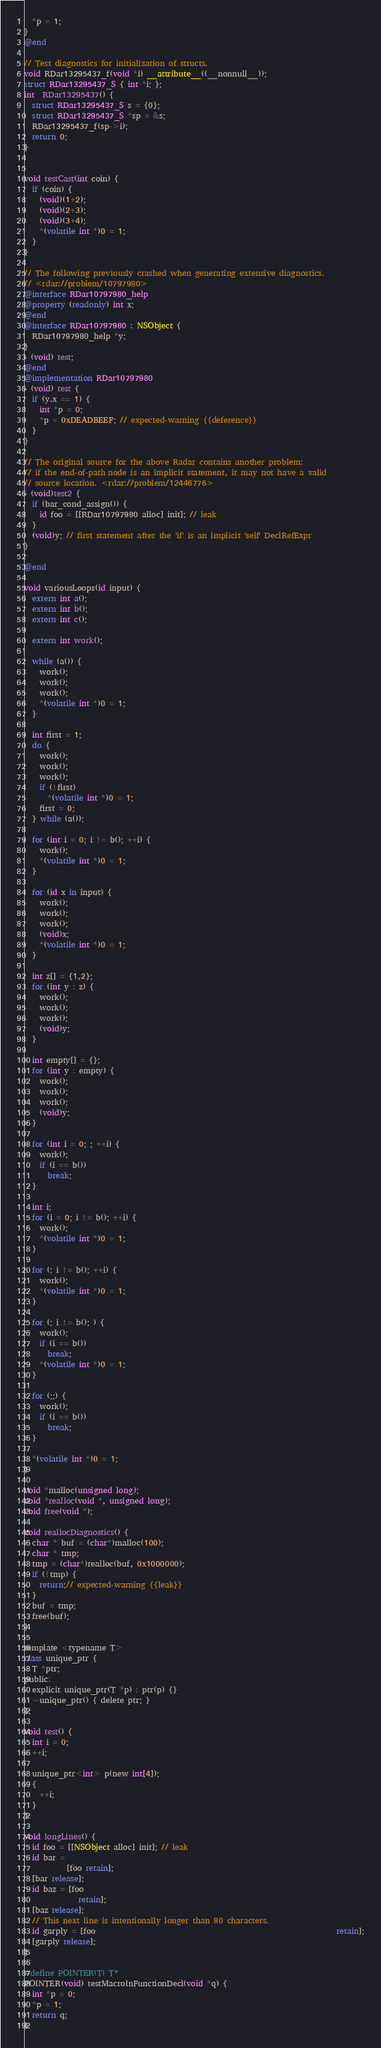Convert code to text. <code><loc_0><loc_0><loc_500><loc_500><_ObjectiveC_>  *p = 1;
}
@end

// Test diagnostics for initialization of structs.
void RDar13295437_f(void *i) __attribute__((__nonnull__));
struct RDar13295437_S { int *i; };
int  RDar13295437() {
  struct RDar13295437_S s = {0};
  struct RDar13295437_S *sp = &s;
  RDar13295437_f(sp->i);
  return 0;
}


void testCast(int coin) {
  if (coin) {
    (void)(1+2);
    (void)(2+3);
    (void)(3+4);
    *(volatile int *)0 = 1;
  }
}

// The following previously crashed when generating extensive diagnostics.
// <rdar://problem/10797980>
@interface RDar10797980_help
@property (readonly) int x;
@end
@interface RDar10797980 : NSObject {
  RDar10797980_help *y;
}
- (void) test;
@end
@implementation RDar10797980
- (void) test {
  if (y.x == 1) {
    int *p = 0;
    *p = 0xDEADBEEF; // expected-warning {{deference}}
  }
}

// The original source for the above Radar contains another problem:
// if the end-of-path node is an implicit statement, it may not have a valid
// source location. <rdar://problem/12446776>
- (void)test2 {
  if (bar_cond_assign()) {
    id foo = [[RDar10797980 alloc] init]; // leak
  }
  (void)y; // first statement after the 'if' is an implicit 'self' DeclRefExpr
}

@end

void variousLoops(id input) {
  extern int a();
  extern int b();
  extern int c();

  extern int work();

  while (a()) {
    work();
    work();
    work();
    *(volatile int *)0 = 1;
  }

  int first = 1;
  do {
    work();
    work();
    work();
    if (!first)
      *(volatile int *)0 = 1;
    first = 0;
  } while (a());

  for (int i = 0; i != b(); ++i) {
    work();
    *(volatile int *)0 = 1;
  }

  for (id x in input) {
    work();
    work();
    work();
    (void)x;
    *(volatile int *)0 = 1;
  }

  int z[] = {1,2};
  for (int y : z) {
    work();
    work();
    work();
    (void)y;
  }

  int empty[] = {};
  for (int y : empty) {
    work();
    work();
    work();
    (void)y;
  }

  for (int i = 0; ; ++i) {
    work();
    if (i == b())
      break;
  }

  int i;
  for (i = 0; i != b(); ++i) {
    work();
    *(volatile int *)0 = 1;
  }

  for (; i != b(); ++i) {
    work();
    *(volatile int *)0 = 1;
  }

  for (; i != b(); ) {
    work();
    if (i == b())
      break;
    *(volatile int *)0 = 1;
  }

  for (;;) {
    work();
    if (i == b())
      break;
  }

  *(volatile int *)0 = 1;
}

void *malloc(unsigned long);
void *realloc(void *, unsigned long);
void free(void *);

void reallocDiagnostics() {
  char * buf = (char*)malloc(100);
  char * tmp;
  tmp = (char*)realloc(buf, 0x1000000);
  if (!tmp) {
    return;// expected-warning {{leak}}
  }
  buf = tmp;
  free(buf);
}

template <typename T>
class unique_ptr {
  T *ptr;
public:
  explicit unique_ptr(T *p) : ptr(p) {}
  ~unique_ptr() { delete ptr; }
};

void test() {
  int i = 0;
  ++i;

  unique_ptr<int> p(new int[4]);
  {
    ++i;
  }
}

void longLines() {
  id foo = [[NSObject alloc] init]; // leak
  id bar =
           [foo retain];
  [bar release];
  id baz = [foo
              retain];
  [baz release];
  // This next line is intentionally longer than 80 characters.
  id garply = [foo                                                              retain];
  [garply release];
}

#define POINTER(T) T*
POINTER(void) testMacroInFunctionDecl(void *q) {
  int *p = 0;
  *p = 1;
  return q;
}
</code> 